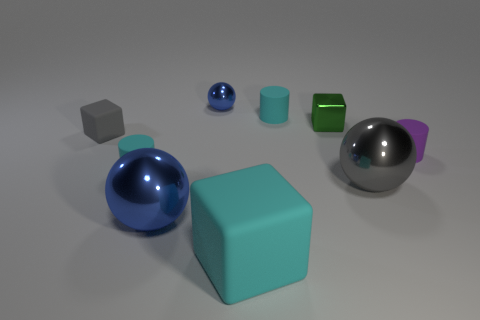What size is the block to the right of the large matte object?
Provide a short and direct response. Small. There is a green thing that is the same shape as the gray rubber object; what is its material?
Ensure brevity in your answer.  Metal. There is a tiny rubber thing on the right side of the large gray metallic thing; what is its shape?
Your answer should be compact. Cylinder. What number of green metal things have the same shape as the small gray matte object?
Provide a short and direct response. 1. Is the number of large blue balls that are right of the gray ball the same as the number of rubber cylinders that are right of the purple rubber thing?
Your answer should be very brief. Yes. Are there any tiny spheres that have the same material as the tiny green cube?
Your answer should be very brief. Yes. Is the material of the large blue thing the same as the tiny sphere?
Your answer should be compact. Yes. What number of gray things are tiny shiny cylinders or metal objects?
Your response must be concise. 1. Is the number of gray matte things on the right side of the large blue object greater than the number of small purple cylinders?
Give a very brief answer. No. Are there any metal balls that have the same color as the small matte block?
Keep it short and to the point. Yes. 